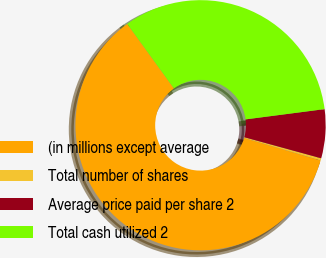Convert chart to OTSL. <chart><loc_0><loc_0><loc_500><loc_500><pie_chart><fcel>(in millions except average<fcel>Total number of shares<fcel>Average price paid per share 2<fcel>Total cash utilized 2<nl><fcel>60.49%<fcel>0.29%<fcel>6.31%<fcel>32.91%<nl></chart> 